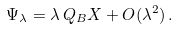<formula> <loc_0><loc_0><loc_500><loc_500>\Psi _ { \lambda } = \lambda \, Q _ { B } X + O ( \lambda ^ { 2 } ) \, .</formula> 